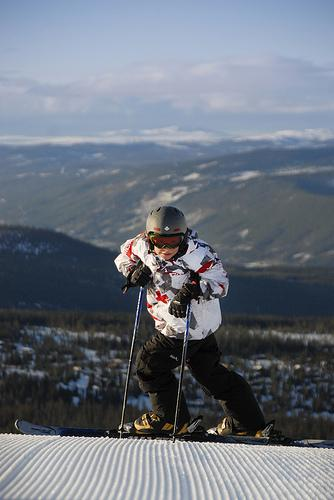Question: how many people are skiing?
Choices:
A. 2.
B. 1.
C. 5.
D. 7.
Answer with the letter. Answer: B Question: where was the photo taken?
Choices:
A. Mountain.
B. In the kitchen.
C. In the tree.
D. On the river.
Answer with the letter. Answer: A Question: when was the photo taken?
Choices:
A. Daytime.
B. Last year.
C. At sunrise.
D. At night.
Answer with the letter. Answer: A 